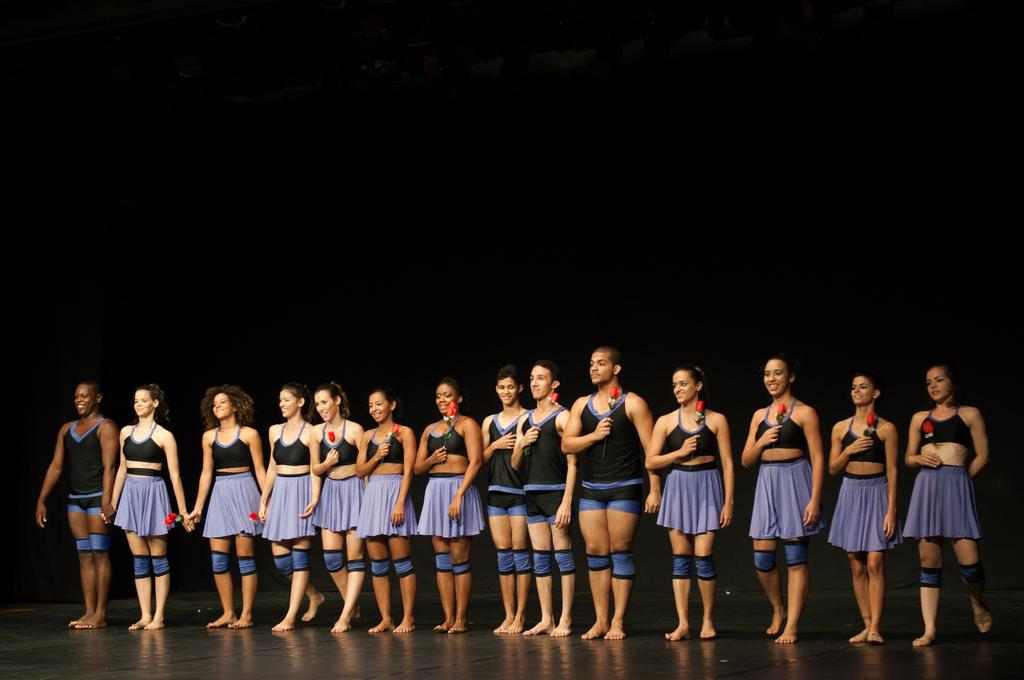What types of people are in the image? There are women and men in the image. What are they wearing? They are wearing the same dresses. What are they holding in their hands? They are holding flowers in their hands. Where are they standing? They are standing on a stage. What expressions do they have? They are smiling. What are they doing in the image? They are giving a pose for the picture. What is the color of the background in the image? The background of the image is dark. What type of cream can be seen on the sofa in the image? There is no sofa or cream present in the image. What event is taking place in the image that led to the birth of a baby? There is no mention of a baby or any event related to childbirth in the image. 